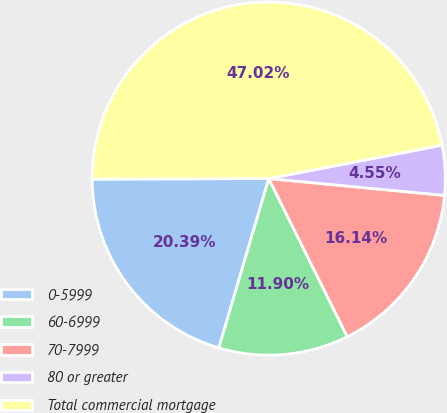Convert chart. <chart><loc_0><loc_0><loc_500><loc_500><pie_chart><fcel>0-5999<fcel>60-6999<fcel>70-7999<fcel>80 or greater<fcel>Total commercial mortgage<nl><fcel>20.39%<fcel>11.9%<fcel>16.14%<fcel>4.55%<fcel>47.02%<nl></chart> 